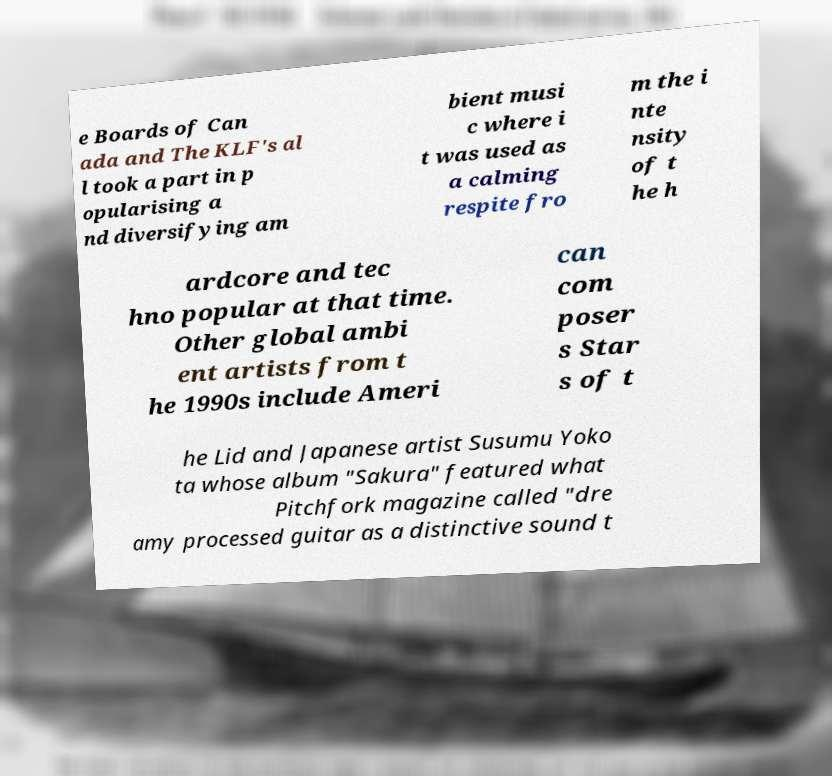Please identify and transcribe the text found in this image. e Boards of Can ada and The KLF's al l took a part in p opularising a nd diversifying am bient musi c where i t was used as a calming respite fro m the i nte nsity of t he h ardcore and tec hno popular at that time. Other global ambi ent artists from t he 1990s include Ameri can com poser s Star s of t he Lid and Japanese artist Susumu Yoko ta whose album "Sakura" featured what Pitchfork magazine called "dre amy processed guitar as a distinctive sound t 